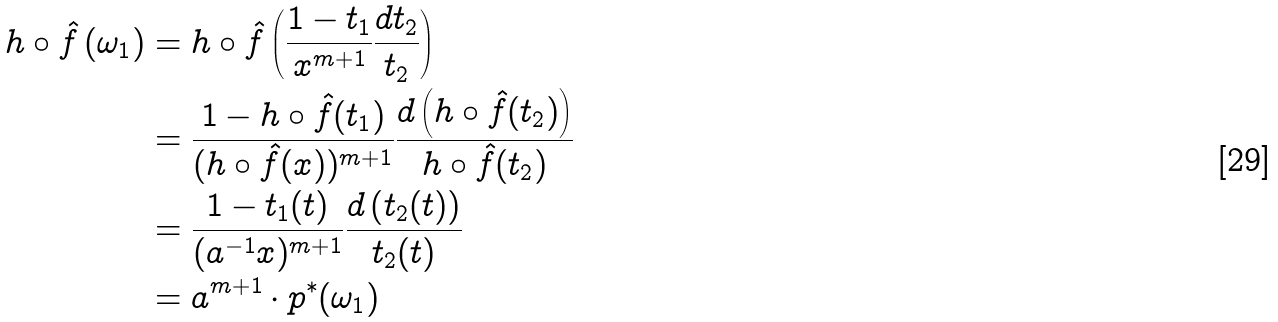Convert formula to latex. <formula><loc_0><loc_0><loc_500><loc_500>h \circ { \hat { f } } \left ( \omega _ { 1 } \right ) & = h \circ { \hat { f } } \left ( { \frac { 1 - t _ { 1 } } { x ^ { m + 1 } } } { \frac { d t _ { 2 } } { t _ { 2 } } } \right ) \\ & = { \frac { 1 - h \circ { \hat { f } } ( t _ { 1 } ) } { ( h \circ { \hat { f } } ( x ) ) ^ { m + 1 } } } { \frac { d \left ( h \circ { \hat { f } } ( t _ { 2 } ) \right ) } { h \circ { \hat { f } } ( t _ { 2 } ) } } \\ & = { \frac { 1 - t _ { 1 } ( t ) } { ( a ^ { - 1 } x ) ^ { m + 1 } } } { \frac { d \left ( t _ { 2 } ( t ) \right ) } { t _ { 2 } ( t ) } } \\ & = a ^ { m + 1 } \cdot p ^ { * } ( \omega _ { 1 } )</formula> 